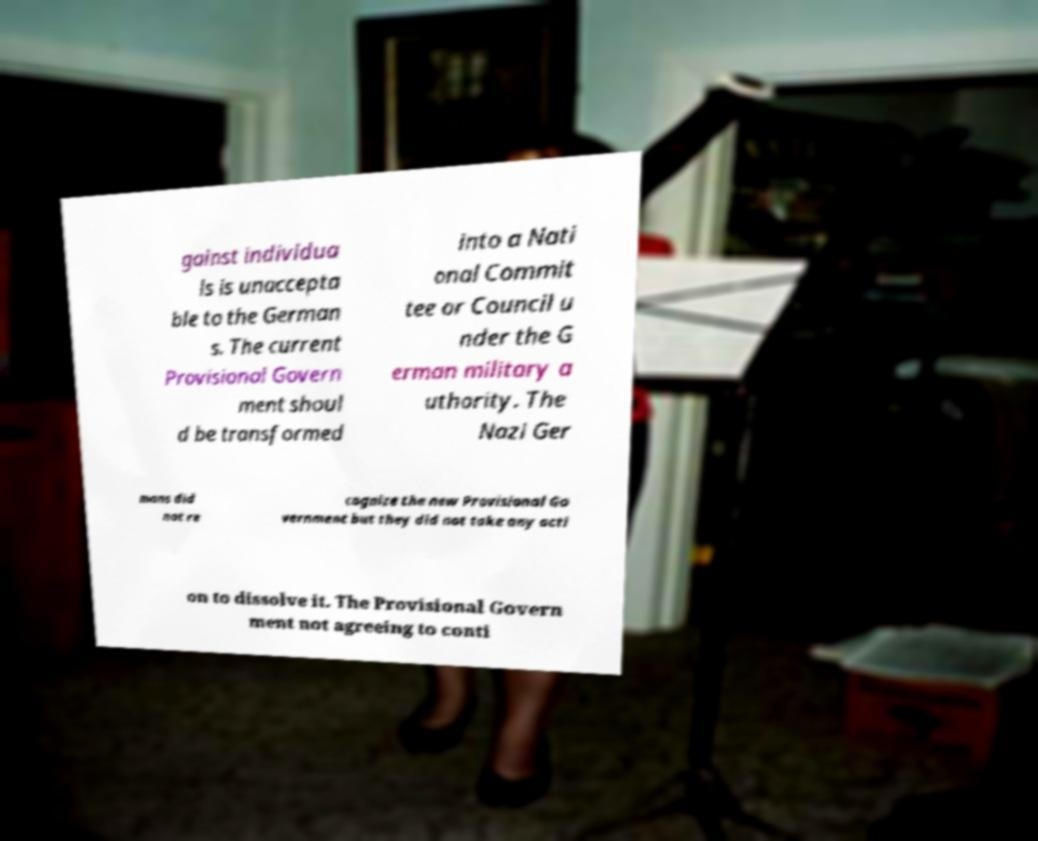Could you extract and type out the text from this image? gainst individua ls is unaccepta ble to the German s. The current Provisional Govern ment shoul d be transformed into a Nati onal Commit tee or Council u nder the G erman military a uthority. The Nazi Ger mans did not re cognize the new Provisional Go vernment but they did not take any acti on to dissolve it. The Provisional Govern ment not agreeing to conti 